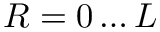Convert formula to latex. <formula><loc_0><loc_0><loc_500><loc_500>R = 0 \dots L</formula> 